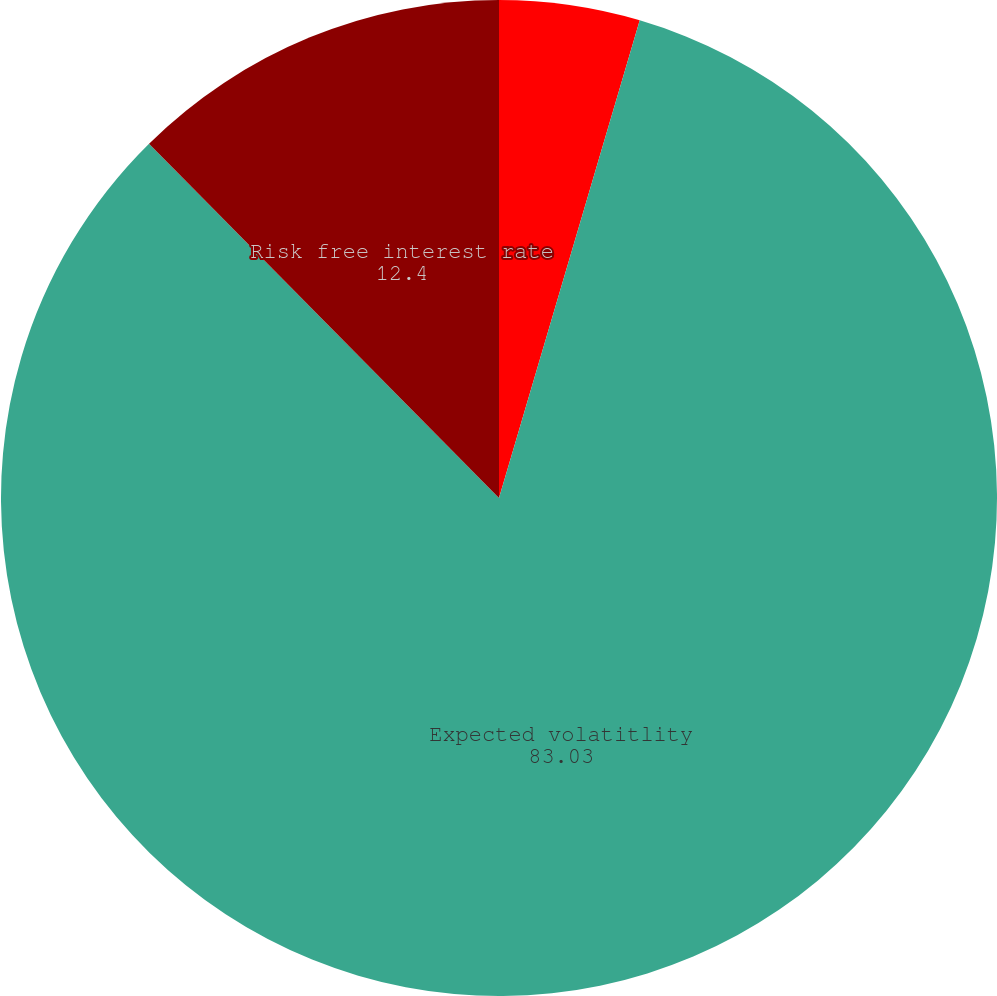<chart> <loc_0><loc_0><loc_500><loc_500><pie_chart><fcel>Dividend yield<fcel>Expected volatitlity<fcel>Risk free interest rate<nl><fcel>4.56%<fcel>83.03%<fcel>12.4%<nl></chart> 